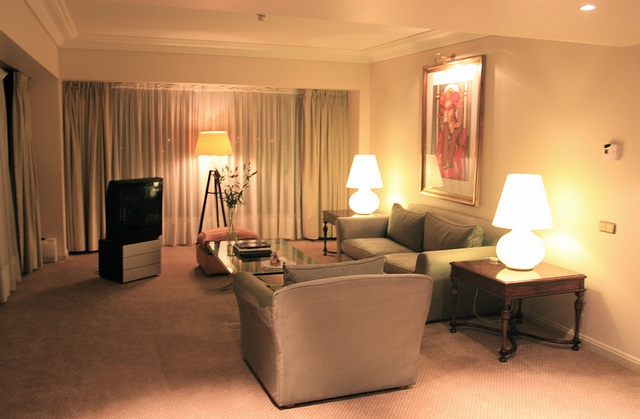Describe the objects in this image and their specific colors. I can see chair in tan, gray, and maroon tones, couch in tan, maroon, gray, and black tones, tv in tan, black, and olive tones, and vase in tan, olive, brown, and gray tones in this image. 